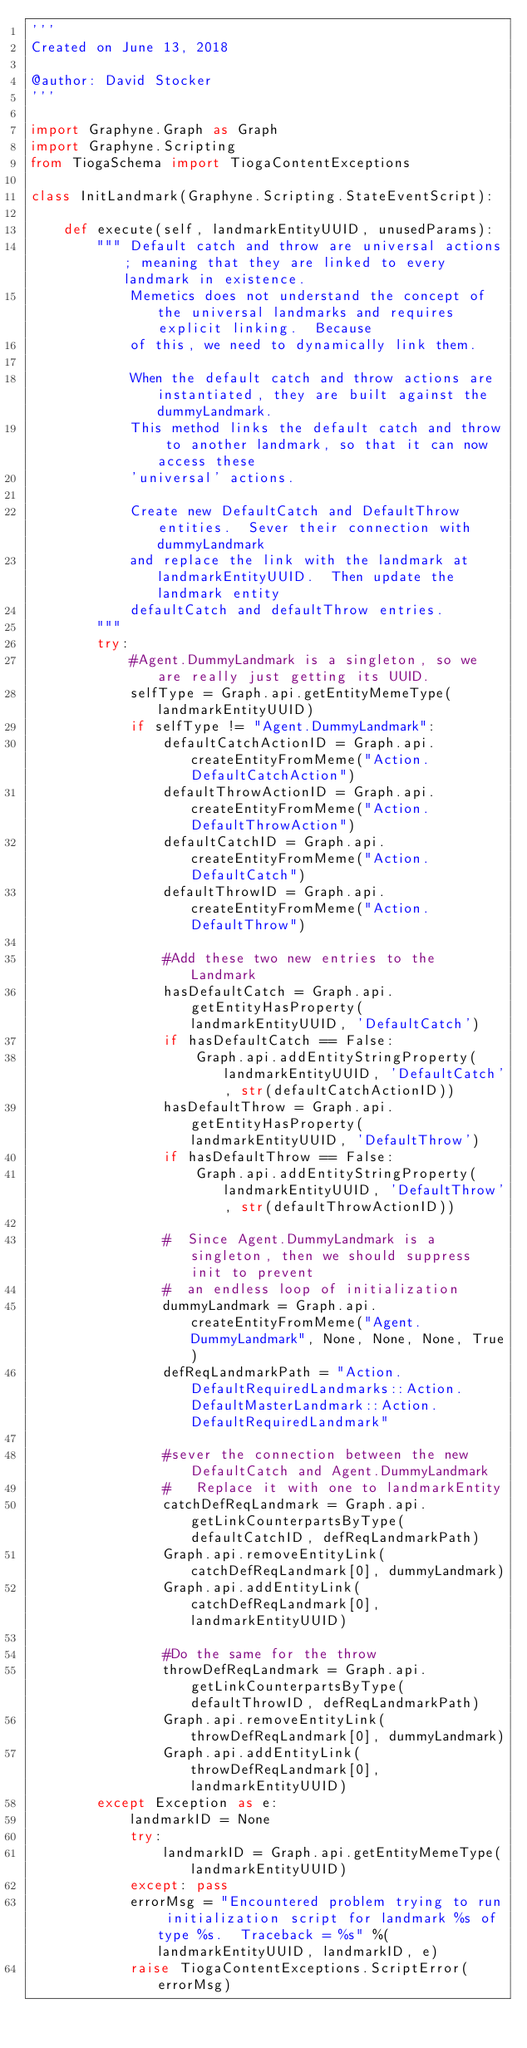Convert code to text. <code><loc_0><loc_0><loc_500><loc_500><_Python_>'''
Created on June 13, 2018

@author: David Stocker
'''

import Graphyne.Graph as Graph
import Graphyne.Scripting
from TiogaSchema import TiogaContentExceptions

class InitLandmark(Graphyne.Scripting.StateEventScript):
    
    def execute(self, landmarkEntityUUID, unusedParams):
        """ Default catch and throw are universal actions; meaning that they are linked to every landmark in existence.  
            Memetics does not understand the concept of the universal landmarks and requires explicit linking.  Because 
            of this, we need to dynamically link them.  

            When the default catch and throw actions are instantiated, they are built against the dummyLandmark.
            This method links the default catch and throw to another landmark, so that it can now access these 
            'universal' actions.  
        
            Create new DefaultCatch and DefaultThrow entities.  Sever their connection with dummyLandmark
            and replace the link with the landmark at landmarkEntityUUID.  Then update the landmark entity
            defaultCatch and defaultThrow entries.
        """
        try:
            #Agent.DummyLandmark is a singleton, so we are really just getting its UUID.
            selfType = Graph.api.getEntityMemeType(landmarkEntityUUID)
            if selfType != "Agent.DummyLandmark":
                defaultCatchActionID = Graph.api.createEntityFromMeme("Action.DefaultCatchAction")
                defaultThrowActionID = Graph.api.createEntityFromMeme("Action.DefaultThrowAction")
                defaultCatchID = Graph.api.createEntityFromMeme("Action.DefaultCatch")
                defaultThrowID = Graph.api.createEntityFromMeme("Action.DefaultThrow")
                
                #Add these two new entries to the Landmark
                hasDefaultCatch = Graph.api.getEntityHasProperty(landmarkEntityUUID, 'DefaultCatch')
                if hasDefaultCatch == False:
                    Graph.api.addEntityStringProperty(landmarkEntityUUID, 'DefaultCatch', str(defaultCatchActionID))
                hasDefaultThrow = Graph.api.getEntityHasProperty(landmarkEntityUUID, 'DefaultThrow')
                if hasDefaultThrow == False:
                    Graph.api.addEntityStringProperty(landmarkEntityUUID, 'DefaultThrow', str(defaultThrowActionID))
                
                #  Since Agent.DummyLandmark is a singleton, then we should suppress init to prevent 
                #  an endless loop of initialization
                dummyLandmark = Graph.api.createEntityFromMeme("Agent.DummyLandmark", None, None, None, True)
                defReqLandmarkPath = "Action.DefaultRequiredLandmarks::Action.DefaultMasterLandmark::Action.DefaultRequiredLandmark"
                        
                #sever the connection between the new DefaultCatch and Agent.DummyLandmark
                #   Replace it with one to landmarkEntity
                catchDefReqLandmark = Graph.api.getLinkCounterpartsByType(defaultCatchID, defReqLandmarkPath)
                Graph.api.removeEntityLink(catchDefReqLandmark[0], dummyLandmark)
                Graph.api.addEntityLink(catchDefReqLandmark[0], landmarkEntityUUID)
                
                #Do the same for the throw
                throwDefReqLandmark = Graph.api.getLinkCounterpartsByType(defaultThrowID, defReqLandmarkPath)
                Graph.api.removeEntityLink(throwDefReqLandmark[0], dummyLandmark)
                Graph.api.addEntityLink(throwDefReqLandmark[0], landmarkEntityUUID)  
        except Exception as e:
            landmarkID = None
            try:
                landmarkID = Graph.api.getEntityMemeType(landmarkEntityUUID)
            except: pass
            errorMsg = "Encountered problem trying to run initialization script for landmark %s of type %s.  Traceback = %s" %(landmarkEntityUUID, landmarkID, e)
            raise TiogaContentExceptions.ScriptError(errorMsg)     </code> 